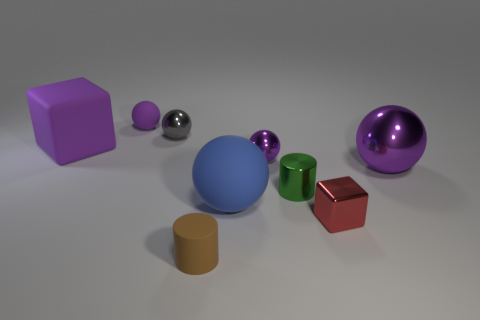Subtract all cyan cylinders. How many purple balls are left? 3 Add 1 big purple rubber objects. How many objects exist? 10 Subtract all cubes. How many objects are left? 7 Subtract 1 blue spheres. How many objects are left? 8 Subtract all small gray matte objects. Subtract all purple metallic spheres. How many objects are left? 7 Add 5 small green objects. How many small green objects are left? 6 Add 1 small purple rubber objects. How many small purple rubber objects exist? 2 